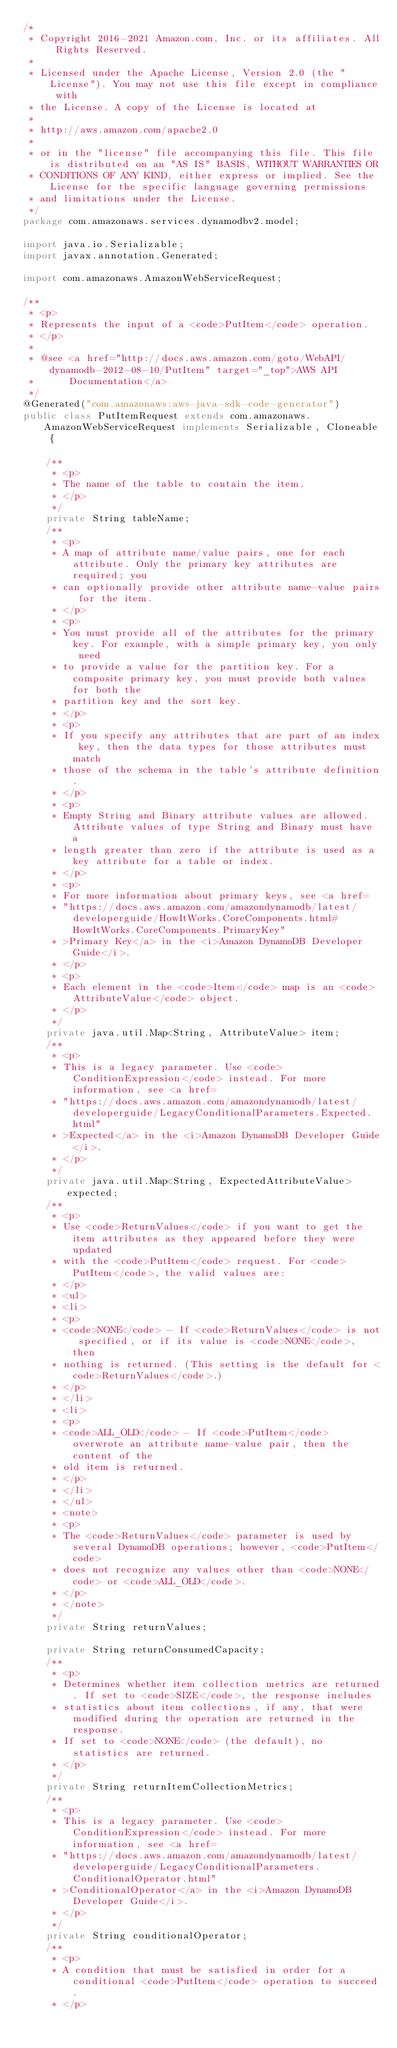Convert code to text. <code><loc_0><loc_0><loc_500><loc_500><_Java_>/*
 * Copyright 2016-2021 Amazon.com, Inc. or its affiliates. All Rights Reserved.
 * 
 * Licensed under the Apache License, Version 2.0 (the "License"). You may not use this file except in compliance with
 * the License. A copy of the License is located at
 * 
 * http://aws.amazon.com/apache2.0
 * 
 * or in the "license" file accompanying this file. This file is distributed on an "AS IS" BASIS, WITHOUT WARRANTIES OR
 * CONDITIONS OF ANY KIND, either express or implied. See the License for the specific language governing permissions
 * and limitations under the License.
 */
package com.amazonaws.services.dynamodbv2.model;

import java.io.Serializable;
import javax.annotation.Generated;

import com.amazonaws.AmazonWebServiceRequest;

/**
 * <p>
 * Represents the input of a <code>PutItem</code> operation.
 * </p>
 * 
 * @see <a href="http://docs.aws.amazon.com/goto/WebAPI/dynamodb-2012-08-10/PutItem" target="_top">AWS API
 *      Documentation</a>
 */
@Generated("com.amazonaws:aws-java-sdk-code-generator")
public class PutItemRequest extends com.amazonaws.AmazonWebServiceRequest implements Serializable, Cloneable {

    /**
     * <p>
     * The name of the table to contain the item.
     * </p>
     */
    private String tableName;
    /**
     * <p>
     * A map of attribute name/value pairs, one for each attribute. Only the primary key attributes are required; you
     * can optionally provide other attribute name-value pairs for the item.
     * </p>
     * <p>
     * You must provide all of the attributes for the primary key. For example, with a simple primary key, you only need
     * to provide a value for the partition key. For a composite primary key, you must provide both values for both the
     * partition key and the sort key.
     * </p>
     * <p>
     * If you specify any attributes that are part of an index key, then the data types for those attributes must match
     * those of the schema in the table's attribute definition.
     * </p>
     * <p>
     * Empty String and Binary attribute values are allowed. Attribute values of type String and Binary must have a
     * length greater than zero if the attribute is used as a key attribute for a table or index.
     * </p>
     * <p>
     * For more information about primary keys, see <a href=
     * "https://docs.aws.amazon.com/amazondynamodb/latest/developerguide/HowItWorks.CoreComponents.html#HowItWorks.CoreComponents.PrimaryKey"
     * >Primary Key</a> in the <i>Amazon DynamoDB Developer Guide</i>.
     * </p>
     * <p>
     * Each element in the <code>Item</code> map is an <code>AttributeValue</code> object.
     * </p>
     */
    private java.util.Map<String, AttributeValue> item;
    /**
     * <p>
     * This is a legacy parameter. Use <code>ConditionExpression</code> instead. For more information, see <a href=
     * "https://docs.aws.amazon.com/amazondynamodb/latest/developerguide/LegacyConditionalParameters.Expected.html"
     * >Expected</a> in the <i>Amazon DynamoDB Developer Guide</i>.
     * </p>
     */
    private java.util.Map<String, ExpectedAttributeValue> expected;
    /**
     * <p>
     * Use <code>ReturnValues</code> if you want to get the item attributes as they appeared before they were updated
     * with the <code>PutItem</code> request. For <code>PutItem</code>, the valid values are:
     * </p>
     * <ul>
     * <li>
     * <p>
     * <code>NONE</code> - If <code>ReturnValues</code> is not specified, or if its value is <code>NONE</code>, then
     * nothing is returned. (This setting is the default for <code>ReturnValues</code>.)
     * </p>
     * </li>
     * <li>
     * <p>
     * <code>ALL_OLD</code> - If <code>PutItem</code> overwrote an attribute name-value pair, then the content of the
     * old item is returned.
     * </p>
     * </li>
     * </ul>
     * <note>
     * <p>
     * The <code>ReturnValues</code> parameter is used by several DynamoDB operations; however, <code>PutItem</code>
     * does not recognize any values other than <code>NONE</code> or <code>ALL_OLD</code>.
     * </p>
     * </note>
     */
    private String returnValues;

    private String returnConsumedCapacity;
    /**
     * <p>
     * Determines whether item collection metrics are returned. If set to <code>SIZE</code>, the response includes
     * statistics about item collections, if any, that were modified during the operation are returned in the response.
     * If set to <code>NONE</code> (the default), no statistics are returned.
     * </p>
     */
    private String returnItemCollectionMetrics;
    /**
     * <p>
     * This is a legacy parameter. Use <code>ConditionExpression</code> instead. For more information, see <a href=
     * "https://docs.aws.amazon.com/amazondynamodb/latest/developerguide/LegacyConditionalParameters.ConditionalOperator.html"
     * >ConditionalOperator</a> in the <i>Amazon DynamoDB Developer Guide</i>.
     * </p>
     */
    private String conditionalOperator;
    /**
     * <p>
     * A condition that must be satisfied in order for a conditional <code>PutItem</code> operation to succeed.
     * </p></code> 